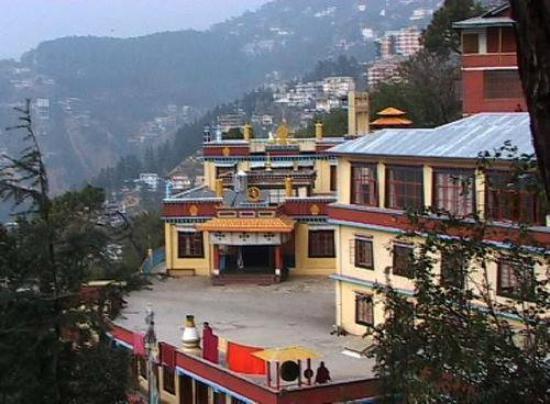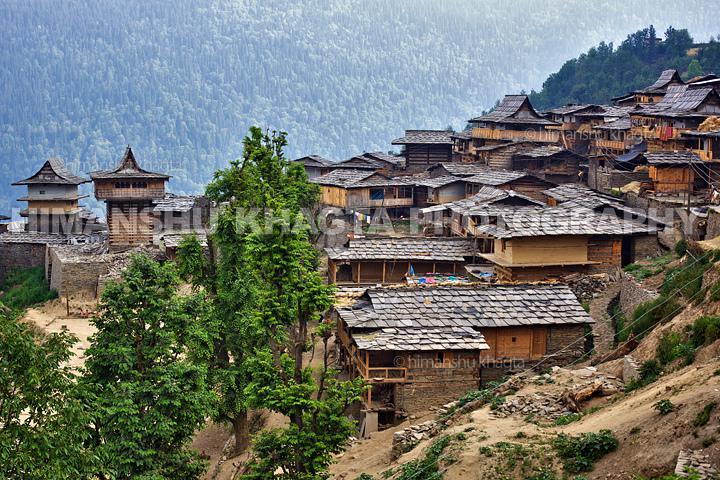The first image is the image on the left, the second image is the image on the right. Assess this claim about the two images: "The roof is pink on the structure in the image on the left.". Correct or not? Answer yes or no. No. 